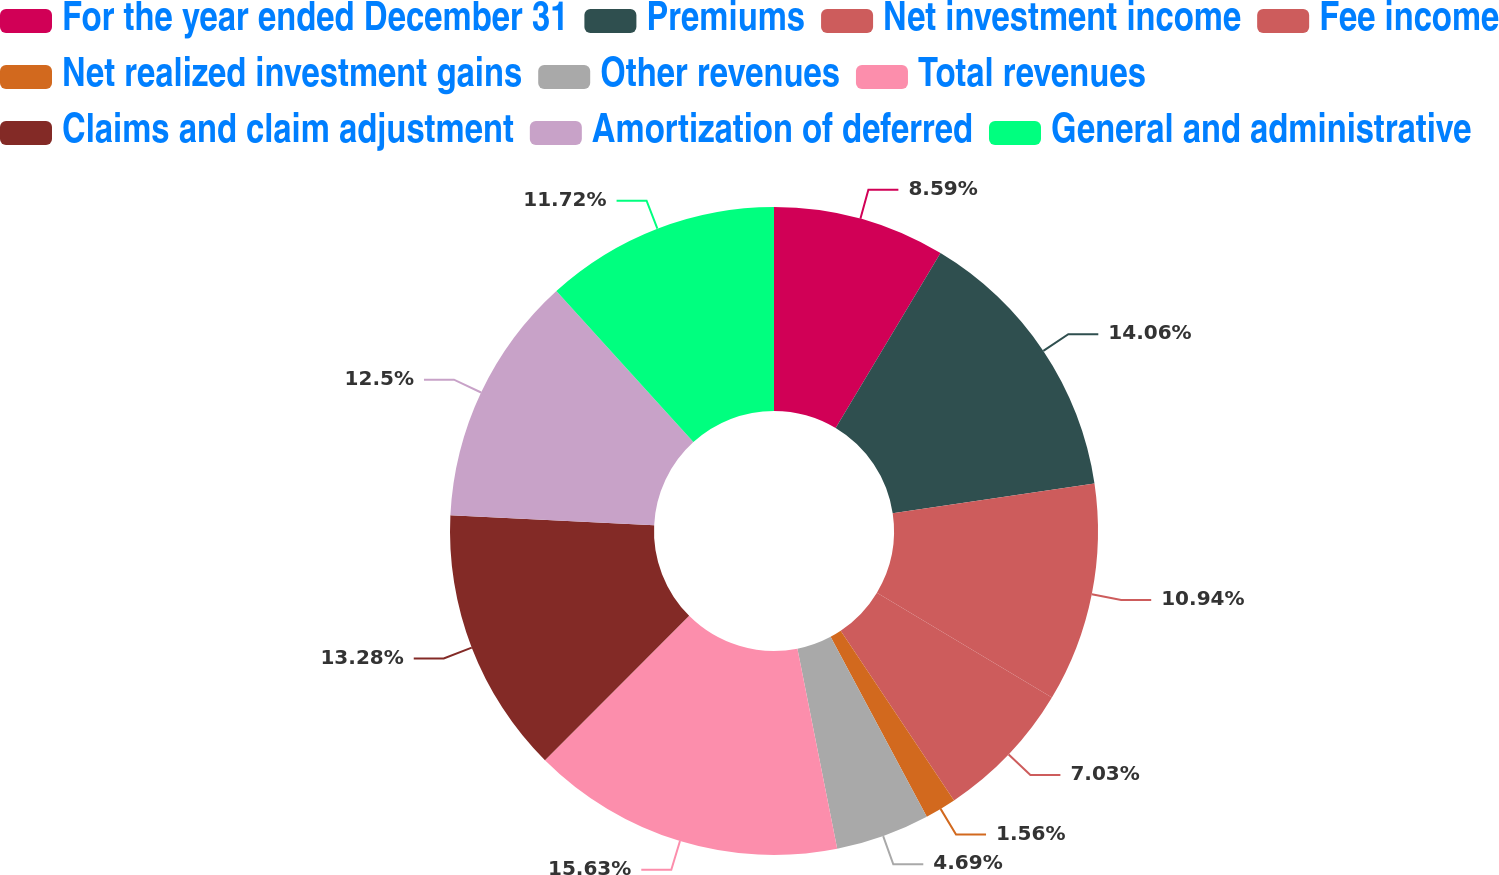<chart> <loc_0><loc_0><loc_500><loc_500><pie_chart><fcel>For the year ended December 31<fcel>Premiums<fcel>Net investment income<fcel>Fee income<fcel>Net realized investment gains<fcel>Other revenues<fcel>Total revenues<fcel>Claims and claim adjustment<fcel>Amortization of deferred<fcel>General and administrative<nl><fcel>8.59%<fcel>14.06%<fcel>10.94%<fcel>7.03%<fcel>1.56%<fcel>4.69%<fcel>15.62%<fcel>13.28%<fcel>12.5%<fcel>11.72%<nl></chart> 